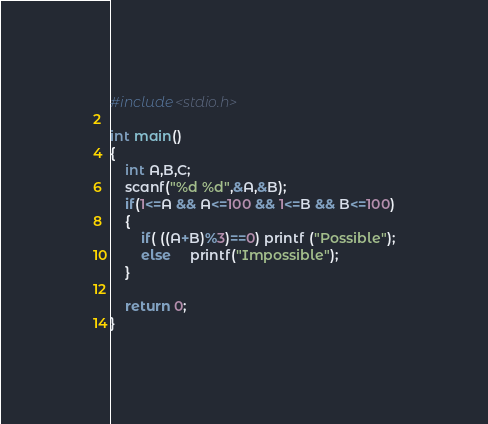<code> <loc_0><loc_0><loc_500><loc_500><_C_>#include<stdio.h>

int main()
{
    int A,B,C;
    scanf("%d %d",&A,&B);
    if(1<=A && A<=100 && 1<=B && B<=100)
    {
        if( ((A+B)%3)==0) printf ("Possible");
        else     printf("Impossible");
    }

    return 0;
}</code> 